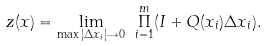<formula> <loc_0><loc_0><loc_500><loc_500>z ( x ) = \underset { \max | \Delta x _ { i } | \rightarrow 0 } { \lim } \text { } \overset { m } { \underset { i = 1 } { \Pi } } ( I + Q ( x _ { i } ) \Delta x _ { i } ) .</formula> 